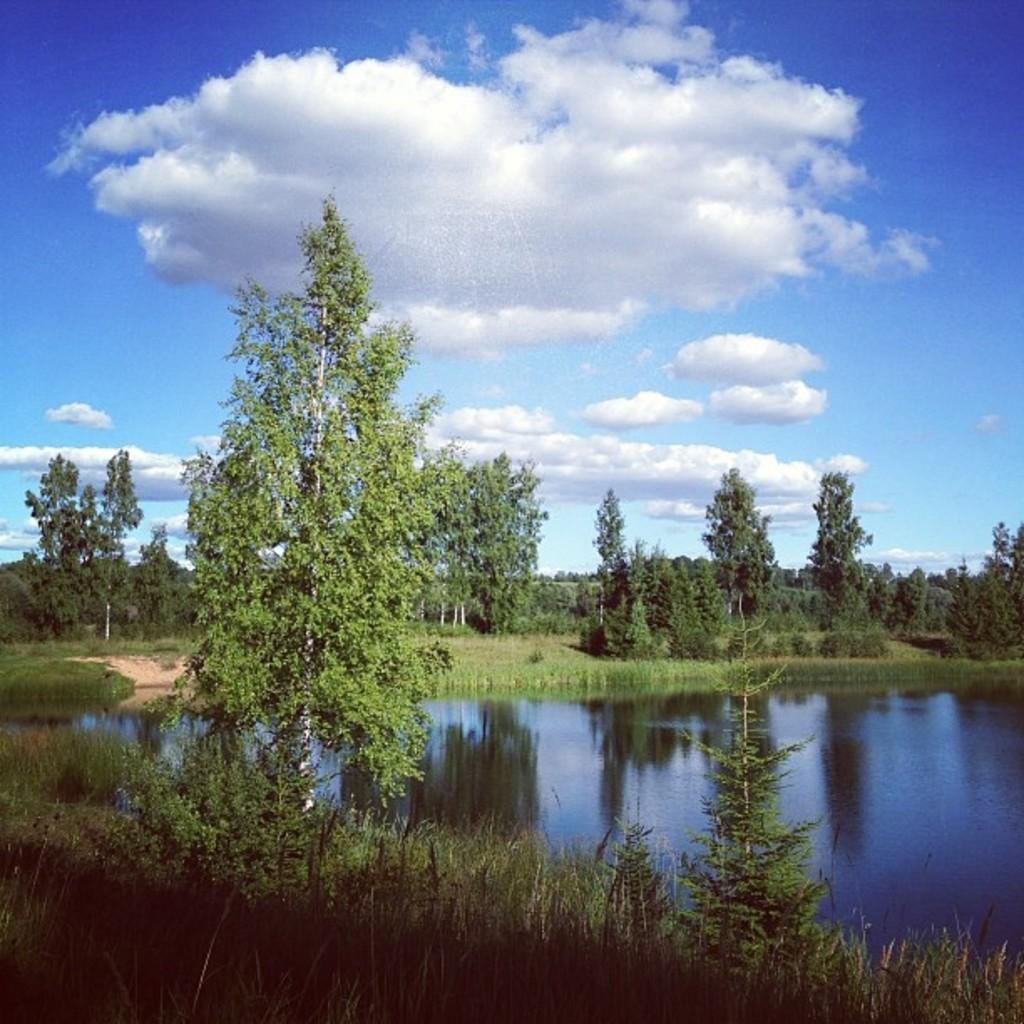Can you describe this image briefly? In the center of the image we can see a pond. In the background there are trees and sky. At the bottom there is grass. 